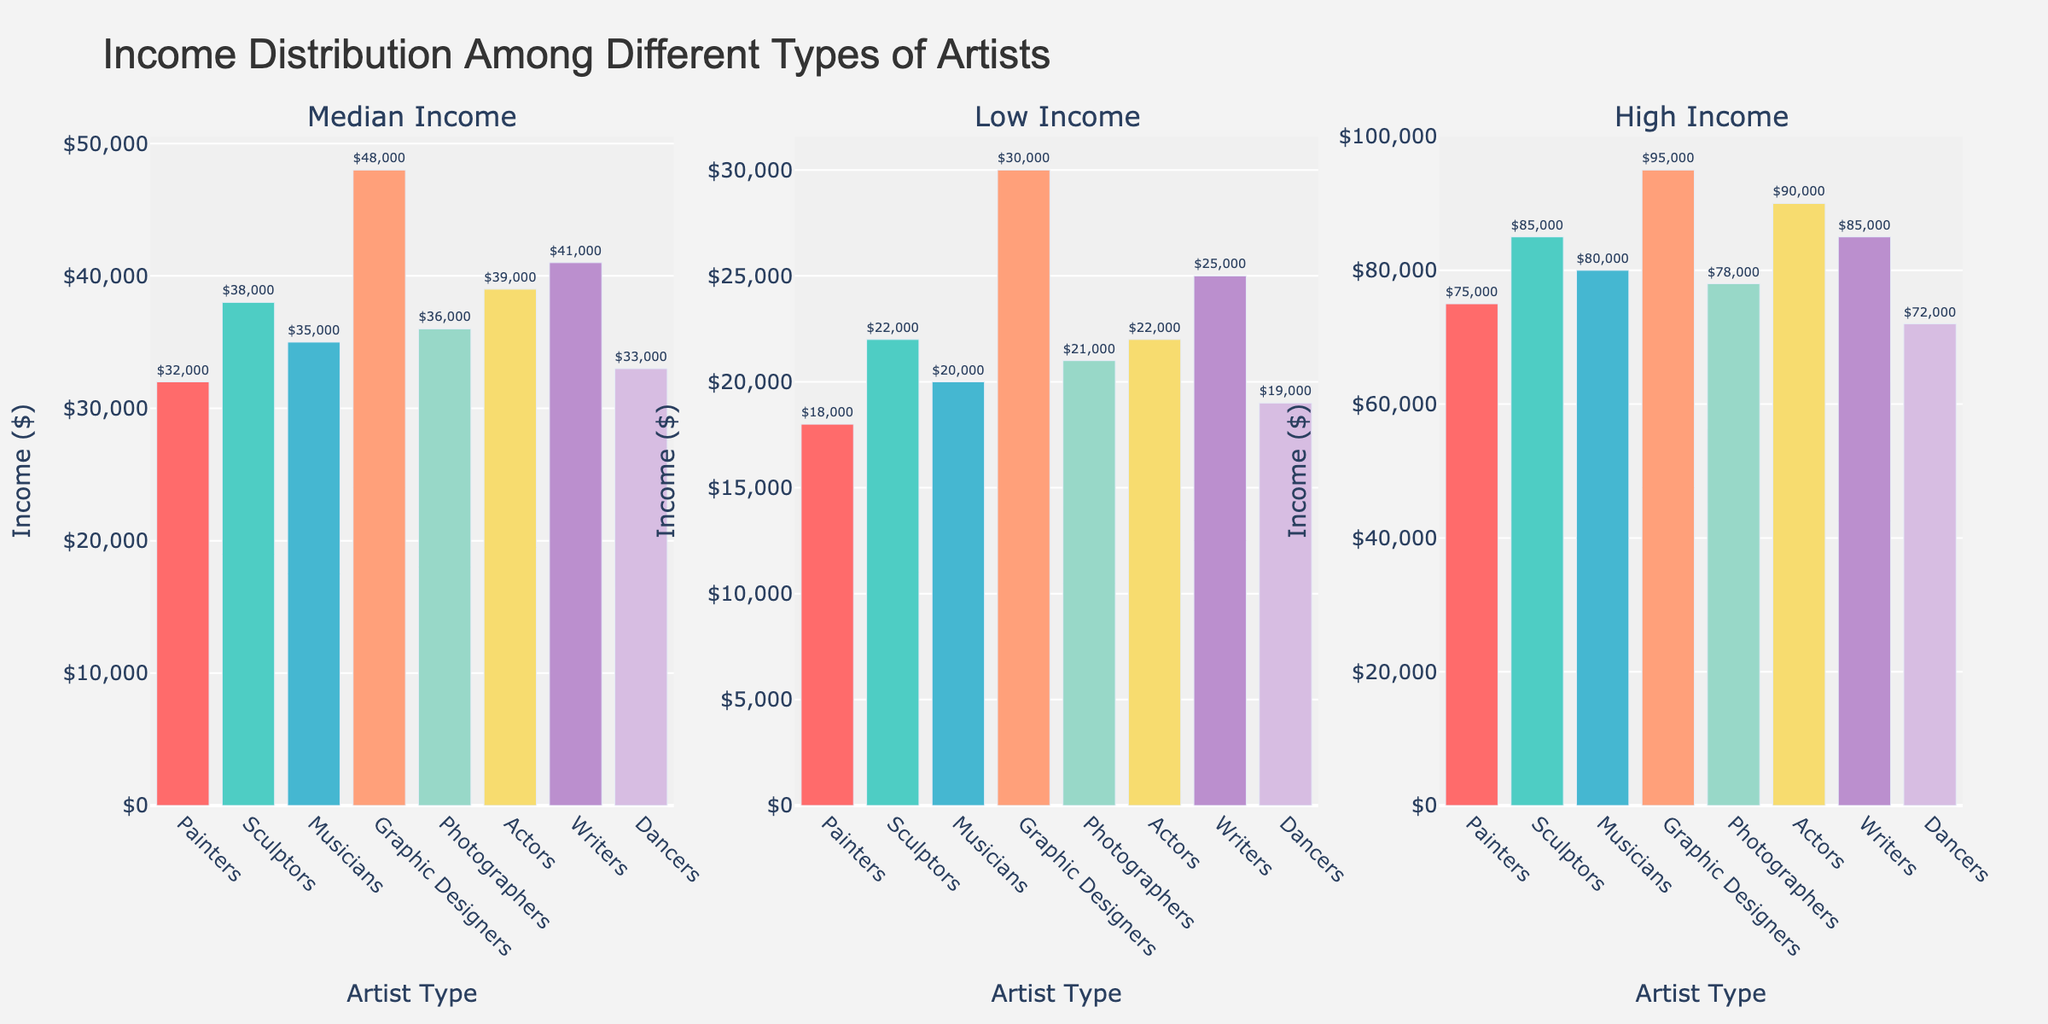How many different conferences are represented in the figure? Look at the legend on the right side of the figure to count the number of unique conference names. There are five different conference names shown.
Answer: 5 Which conference has the program with the highest win percentage? Identify the marker that corresponds to the highest value on the x-axis (Win Percentage). The UConn program from the Big East conference has the highest win percentage.
Answer: Big East What is the range of player development scores depicted on the y-axis? Check the lowest and highest values on the y-axis. The player development scores range from 75 to 95.
Answer: 75 to 95 How does Stanford's recruitment success rate compare to Baylor's? Locate the markers for Stanford and Baylor by finding the corresponding program names in the annotations. Compare the sizes and colors of their markers. Stanford’s marker is slightly larger and darker, indicating a higher recruitment success rate compared to Baylor.
Answer: Higher What's the average win percentage across all Big Ten programs? Identify and list the win percentages of the Big Ten programs: Maryland (0.70) and Ohio State (0.68). Sum these percentages and divide by the number of Big Ten programs (2). The average is (0.70 + 0.68) / 2 = 0.69.
Answer: 0.69 Which program ranks higher in player development score, Texas A&M or NC State? Locate the markers for Texas A&M and NC State by finding their corresponding values on the y-axis. Texas A&M has a player development score of 82 while NC State has a score of 77. Therefore, Texas A&M ranks higher.
Answer: Texas A&M Are there any programs with both a recruitment success rate below 80 and a player development score above 80? Examine the size and color of the markers that fall above 80 on the y-axis (Player Development Score) and also have a color indicating a recruitment success rate lower than 80. There are no programs that meet both criteria.
Answer: No What is the difference in win percentage between the programs with the highest and lowest player development scores? Identify the programs with the highest (UConn, 0.85) and lowest (NC State, 0.65) player development scores, and find their win percentages. Subtract the lowest win percentage from the highest (0.85 - 0.65). The difference is 0.20.
Answer: 0.20 Which conference has the most consistent recruitment success rate across its programs? Compare the colors of the markers within each conference. The Pac-12 has relatively consistent colors, indicating a consistent recruitment success rate across its programs.
Answer: Pac-12 